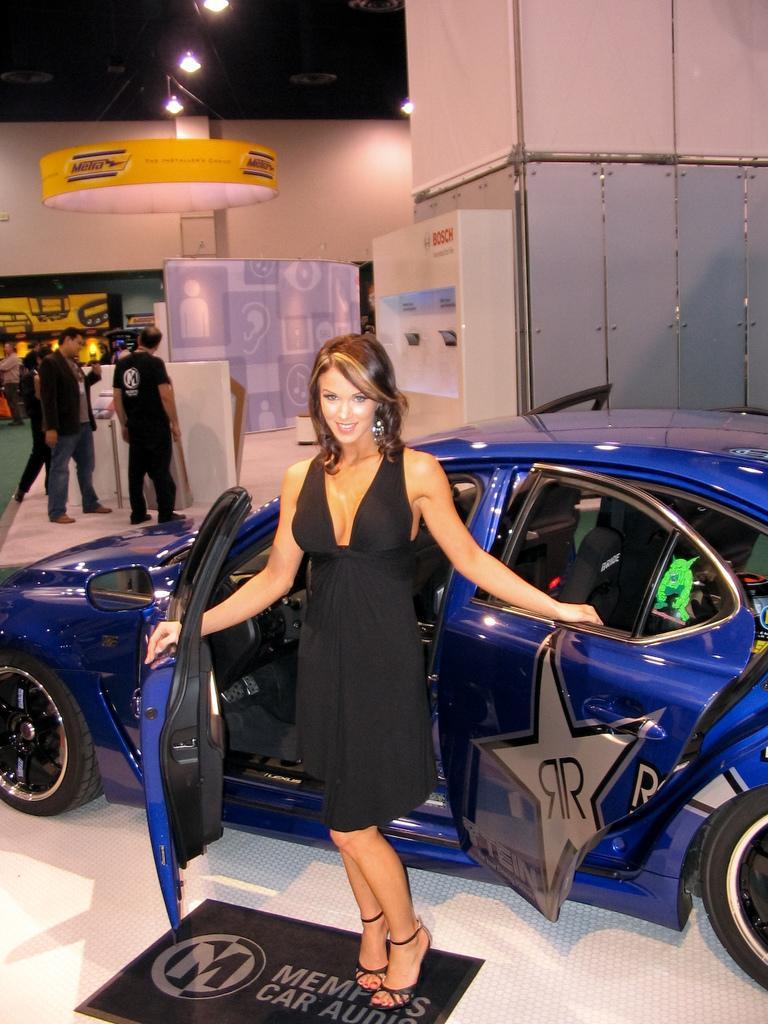Please provide a concise description of this image. In this image I can see a woman wearing black color dress is standing and I can see a blue colored car behind her on the white colored surface. In the background I can see few other persons , the white colored wall, the ceiling and few lights to the ceiling. 